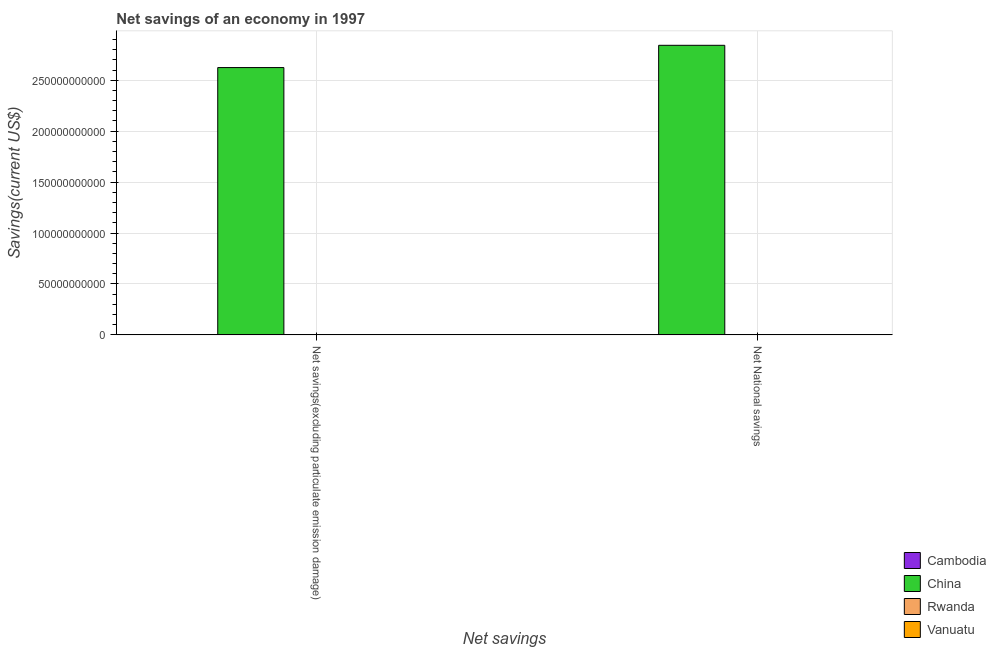How many bars are there on the 1st tick from the right?
Ensure brevity in your answer.  4. What is the label of the 1st group of bars from the left?
Provide a succinct answer. Net savings(excluding particulate emission damage). What is the net national savings in China?
Offer a terse response. 2.84e+11. Across all countries, what is the maximum net national savings?
Your answer should be very brief. 2.84e+11. Across all countries, what is the minimum net savings(excluding particulate emission damage)?
Give a very brief answer. 0. In which country was the net national savings maximum?
Provide a short and direct response. China. What is the total net national savings in the graph?
Offer a very short reply. 2.84e+11. What is the difference between the net national savings in Cambodia and that in China?
Offer a terse response. -2.84e+11. What is the difference between the net savings(excluding particulate emission damage) in Rwanda and the net national savings in China?
Give a very brief answer. -2.84e+11. What is the average net savings(excluding particulate emission damage) per country?
Make the answer very short. 6.56e+1. What is the difference between the net savings(excluding particulate emission damage) and net national savings in China?
Provide a short and direct response. -2.19e+1. In how many countries, is the net savings(excluding particulate emission damage) greater than 80000000000 US$?
Make the answer very short. 1. What is the ratio of the net national savings in Cambodia to that in China?
Your response must be concise. 8.261857366474072e-5. Is the net savings(excluding particulate emission damage) in Vanuatu less than that in China?
Keep it short and to the point. Yes. How many countries are there in the graph?
Your answer should be very brief. 4. Does the graph contain grids?
Ensure brevity in your answer.  Yes. How many legend labels are there?
Provide a short and direct response. 4. How are the legend labels stacked?
Your answer should be very brief. Vertical. What is the title of the graph?
Offer a very short reply. Net savings of an economy in 1997. Does "St. Vincent and the Grenadines" appear as one of the legend labels in the graph?
Ensure brevity in your answer.  No. What is the label or title of the X-axis?
Provide a succinct answer. Net savings. What is the label or title of the Y-axis?
Provide a succinct answer. Savings(current US$). What is the Savings(current US$) of China in Net savings(excluding particulate emission damage)?
Keep it short and to the point. 2.62e+11. What is the Savings(current US$) in Rwanda in Net savings(excluding particulate emission damage)?
Your answer should be compact. 0. What is the Savings(current US$) of Vanuatu in Net savings(excluding particulate emission damage)?
Offer a very short reply. 2.03e+07. What is the Savings(current US$) in Cambodia in Net National savings?
Provide a short and direct response. 2.35e+07. What is the Savings(current US$) in China in Net National savings?
Your answer should be compact. 2.84e+11. What is the Savings(current US$) of Rwanda in Net National savings?
Make the answer very short. 1.18e+07. What is the Savings(current US$) in Vanuatu in Net National savings?
Offer a terse response. 6.51e+06. Across all Net savings, what is the maximum Savings(current US$) in Cambodia?
Your answer should be very brief. 2.35e+07. Across all Net savings, what is the maximum Savings(current US$) in China?
Provide a succinct answer. 2.84e+11. Across all Net savings, what is the maximum Savings(current US$) in Rwanda?
Give a very brief answer. 1.18e+07. Across all Net savings, what is the maximum Savings(current US$) in Vanuatu?
Offer a very short reply. 2.03e+07. Across all Net savings, what is the minimum Savings(current US$) in China?
Your answer should be compact. 2.62e+11. Across all Net savings, what is the minimum Savings(current US$) of Rwanda?
Your response must be concise. 0. Across all Net savings, what is the minimum Savings(current US$) in Vanuatu?
Your response must be concise. 6.51e+06. What is the total Savings(current US$) in Cambodia in the graph?
Ensure brevity in your answer.  2.35e+07. What is the total Savings(current US$) of China in the graph?
Your answer should be very brief. 5.47e+11. What is the total Savings(current US$) of Rwanda in the graph?
Make the answer very short. 1.18e+07. What is the total Savings(current US$) of Vanuatu in the graph?
Provide a succinct answer. 2.68e+07. What is the difference between the Savings(current US$) in China in Net savings(excluding particulate emission damage) and that in Net National savings?
Your answer should be very brief. -2.19e+1. What is the difference between the Savings(current US$) in Vanuatu in Net savings(excluding particulate emission damage) and that in Net National savings?
Provide a succinct answer. 1.38e+07. What is the difference between the Savings(current US$) in China in Net savings(excluding particulate emission damage) and the Savings(current US$) in Rwanda in Net National savings?
Keep it short and to the point. 2.62e+11. What is the difference between the Savings(current US$) in China in Net savings(excluding particulate emission damage) and the Savings(current US$) in Vanuatu in Net National savings?
Offer a terse response. 2.62e+11. What is the average Savings(current US$) in Cambodia per Net savings?
Provide a succinct answer. 1.17e+07. What is the average Savings(current US$) in China per Net savings?
Offer a very short reply. 2.73e+11. What is the average Savings(current US$) of Rwanda per Net savings?
Make the answer very short. 5.90e+06. What is the average Savings(current US$) of Vanuatu per Net savings?
Provide a short and direct response. 1.34e+07. What is the difference between the Savings(current US$) of China and Savings(current US$) of Vanuatu in Net savings(excluding particulate emission damage)?
Make the answer very short. 2.62e+11. What is the difference between the Savings(current US$) in Cambodia and Savings(current US$) in China in Net National savings?
Give a very brief answer. -2.84e+11. What is the difference between the Savings(current US$) in Cambodia and Savings(current US$) in Rwanda in Net National savings?
Make the answer very short. 1.17e+07. What is the difference between the Savings(current US$) in Cambodia and Savings(current US$) in Vanuatu in Net National savings?
Your answer should be compact. 1.70e+07. What is the difference between the Savings(current US$) in China and Savings(current US$) in Rwanda in Net National savings?
Provide a short and direct response. 2.84e+11. What is the difference between the Savings(current US$) of China and Savings(current US$) of Vanuatu in Net National savings?
Make the answer very short. 2.84e+11. What is the difference between the Savings(current US$) of Rwanda and Savings(current US$) of Vanuatu in Net National savings?
Your response must be concise. 5.28e+06. What is the ratio of the Savings(current US$) of China in Net savings(excluding particulate emission damage) to that in Net National savings?
Provide a succinct answer. 0.92. What is the ratio of the Savings(current US$) in Vanuatu in Net savings(excluding particulate emission damage) to that in Net National savings?
Offer a terse response. 3.12. What is the difference between the highest and the second highest Savings(current US$) of China?
Your answer should be very brief. 2.19e+1. What is the difference between the highest and the second highest Savings(current US$) in Vanuatu?
Your response must be concise. 1.38e+07. What is the difference between the highest and the lowest Savings(current US$) of Cambodia?
Your response must be concise. 2.35e+07. What is the difference between the highest and the lowest Savings(current US$) in China?
Provide a short and direct response. 2.19e+1. What is the difference between the highest and the lowest Savings(current US$) of Rwanda?
Your answer should be very brief. 1.18e+07. What is the difference between the highest and the lowest Savings(current US$) of Vanuatu?
Ensure brevity in your answer.  1.38e+07. 